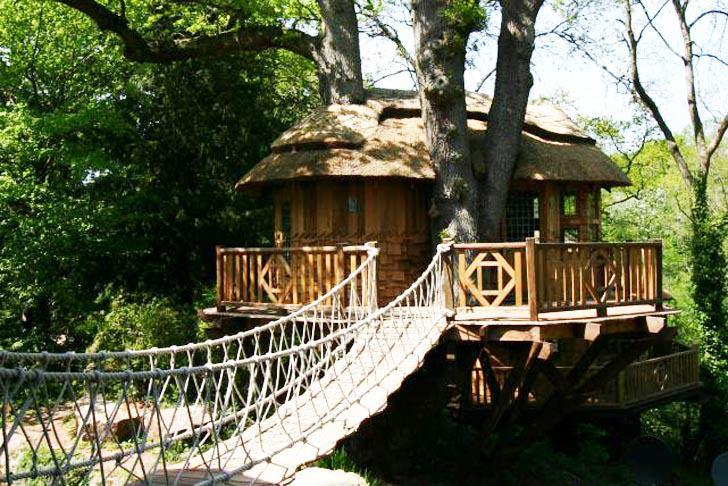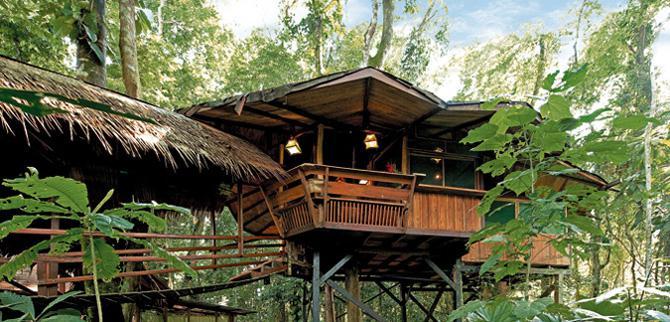The first image is the image on the left, the second image is the image on the right. For the images displayed, is the sentence "there is a tree house with a bridge leading to it, in front of the house there are two tree trunks and there is one trunk behind" factually correct? Answer yes or no. Yes. The first image is the image on the left, the second image is the image on the right. Considering the images on both sides, is "A rope walkway leads from the lower left to an elevated treehouse surrounded by a deck with railing." valid? Answer yes or no. Yes. 